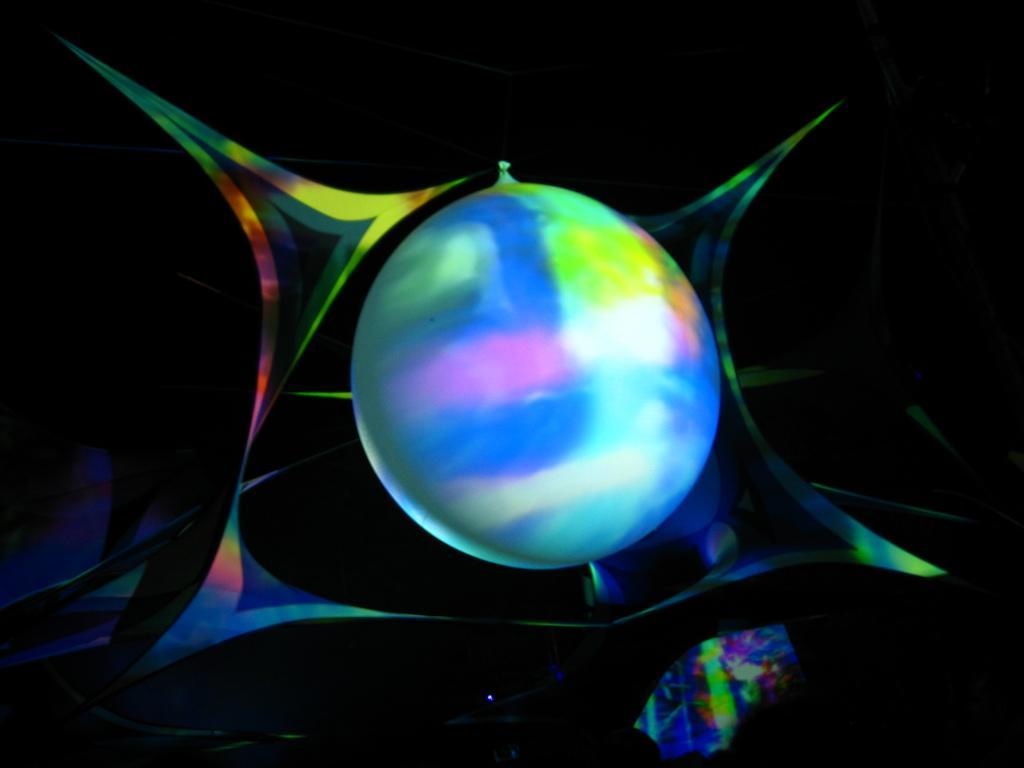Describe this image in one or two sentences. In this image I can see a colorful ball. 